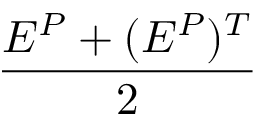Convert formula to latex. <formula><loc_0><loc_0><loc_500><loc_500>\frac { E ^ { P } + ( E ^ { P } ) ^ { T } } { 2 }</formula> 